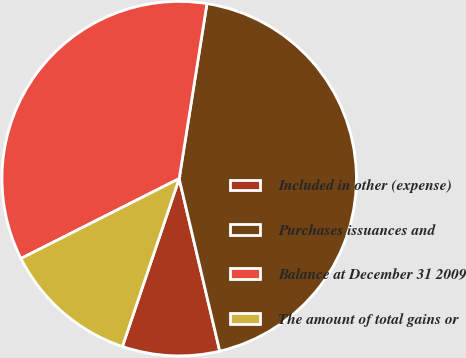Convert chart. <chart><loc_0><loc_0><loc_500><loc_500><pie_chart><fcel>Included in other (expense)<fcel>Purchases issuances and<fcel>Balance at December 31 2009<fcel>The amount of total gains or<nl><fcel>8.87%<fcel>43.82%<fcel>34.95%<fcel>12.37%<nl></chart> 